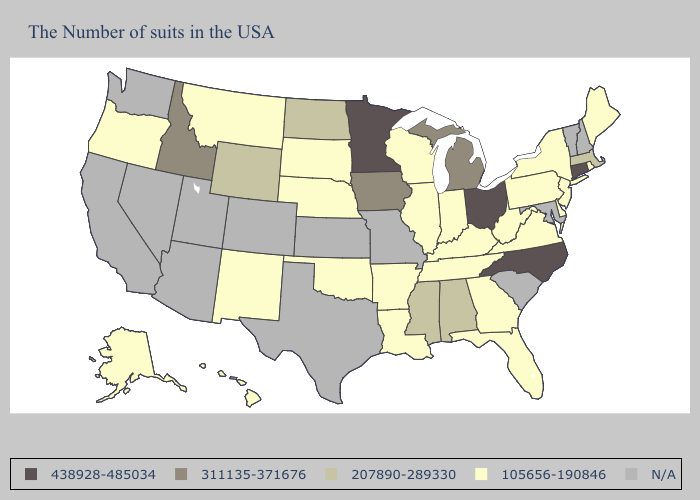Does Wyoming have the lowest value in the West?
Answer briefly. No. Does Oregon have the highest value in the West?
Answer briefly. No. What is the value of Alabama?
Quick response, please. 207890-289330. What is the highest value in the USA?
Concise answer only. 438928-485034. Does South Dakota have the lowest value in the MidWest?
Quick response, please. Yes. What is the value of New Mexico?
Write a very short answer. 105656-190846. What is the value of Iowa?
Short answer required. 311135-371676. What is the lowest value in states that border Missouri?
Answer briefly. 105656-190846. What is the value of Nebraska?
Concise answer only. 105656-190846. Among the states that border Iowa , does Minnesota have the highest value?
Keep it brief. Yes. Name the states that have a value in the range 207890-289330?
Quick response, please. Massachusetts, Alabama, Mississippi, North Dakota, Wyoming. Which states have the lowest value in the South?
Be succinct. Delaware, Virginia, West Virginia, Florida, Georgia, Kentucky, Tennessee, Louisiana, Arkansas, Oklahoma. Among the states that border Alabama , does Mississippi have the lowest value?
Keep it brief. No. 